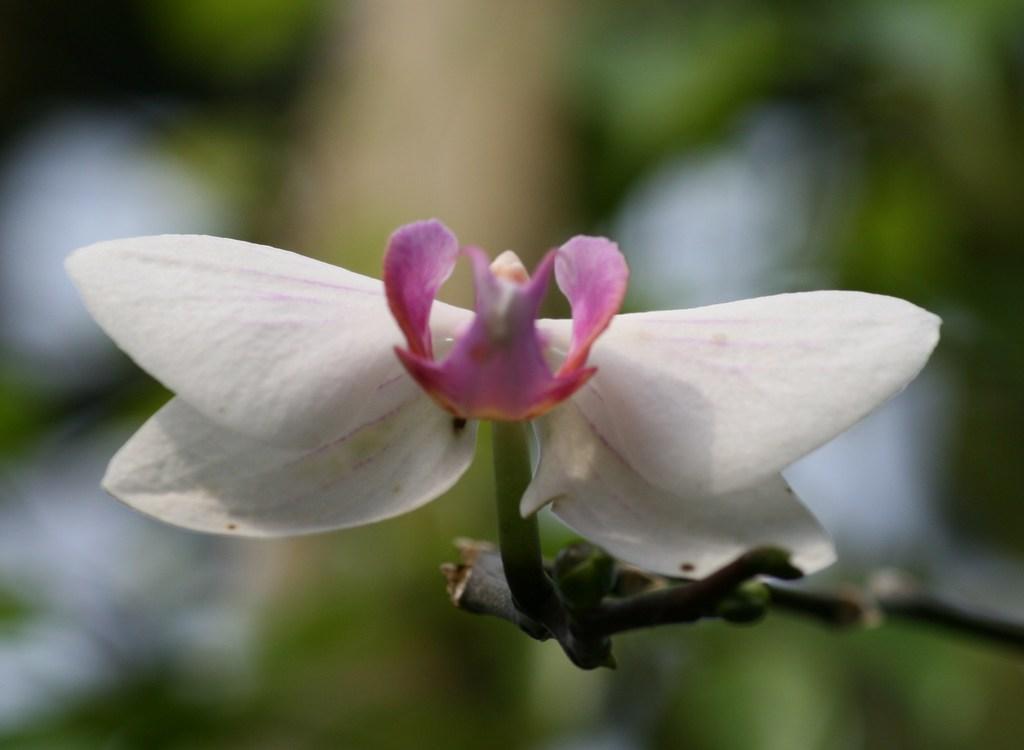In one or two sentences, can you explain what this image depicts? The picture consist of a flower and a stem. The background is blurred. In the background there is greenery. 